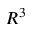<formula> <loc_0><loc_0><loc_500><loc_500>R ^ { 3 }</formula> 